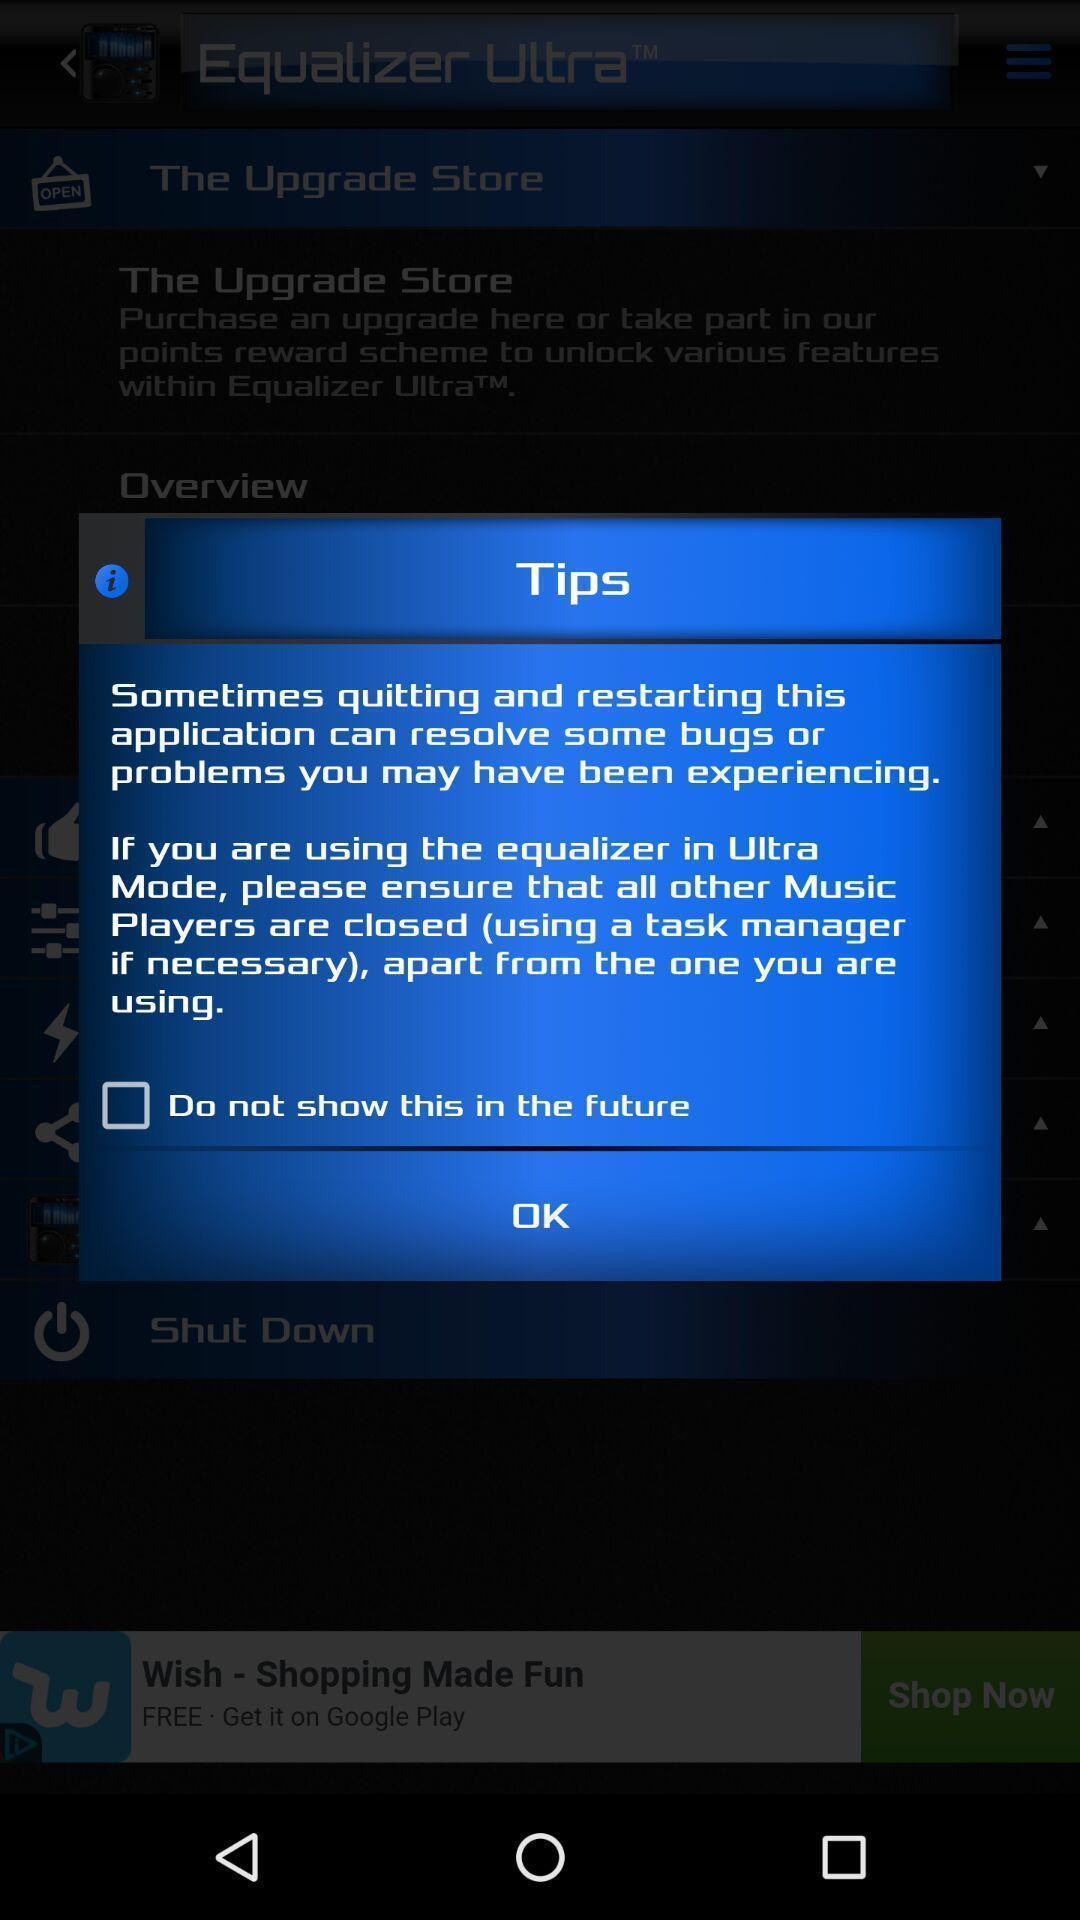Describe the key features of this screenshot. Pop-up shows list of tips. 